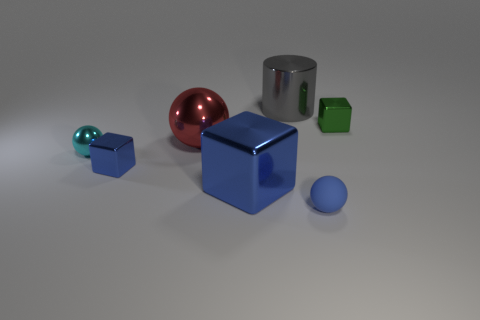Subtract all blue cubes. How many were subtracted if there are1blue cubes left? 1 Subtract 1 balls. How many balls are left? 2 Add 1 blue metallic blocks. How many objects exist? 8 Subtract all cubes. How many objects are left? 4 Add 6 tiny blue shiny cylinders. How many tiny blue shiny cylinders exist? 6 Subtract 0 green spheres. How many objects are left? 7 Subtract all big blue objects. Subtract all blue metallic things. How many objects are left? 4 Add 6 small cubes. How many small cubes are left? 8 